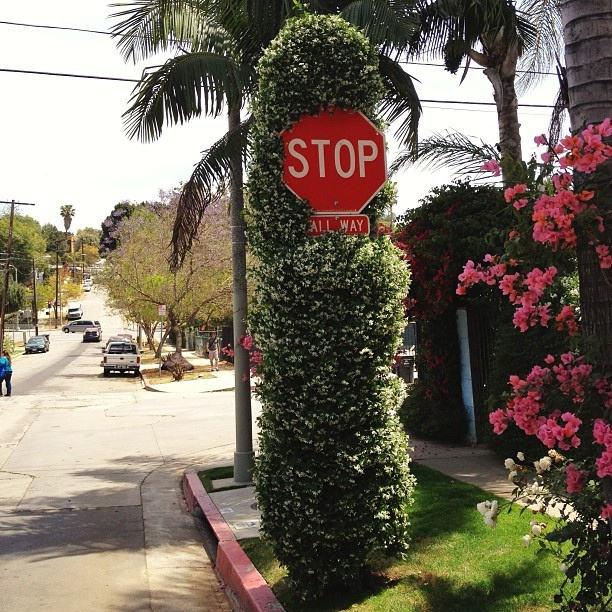Describe the objects in this image and their specific colors. I can see stop sign in white, maroon, gray, and brown tones, truck in white, black, darkgray, gray, and tan tones, people in white, gray, black, and maroon tones, people in white, black, navy, blue, and gray tones, and car in white, gray, black, and darkgray tones in this image. 